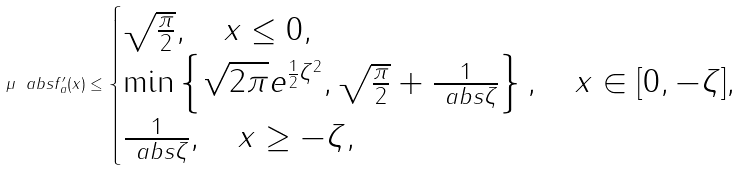Convert formula to latex. <formula><loc_0><loc_0><loc_500><loc_500>\mu \ a b s { f _ { a } ^ { \prime } ( x ) } \leq \begin{cases} \sqrt { \frac { \pi } { 2 } } , \quad x \leq 0 , \\ \min \left \{ \sqrt { 2 \pi } e ^ { \frac { 1 } { 2 } \zeta ^ { 2 } } , \sqrt { \frac { \pi } { 2 } } + \frac { 1 } { \ a b s { \zeta } } \right \} , \quad x \in [ 0 , - \zeta ] , \\ \frac { 1 } { \ a b s { \zeta } } , \quad x \geq - \zeta , \end{cases}</formula> 